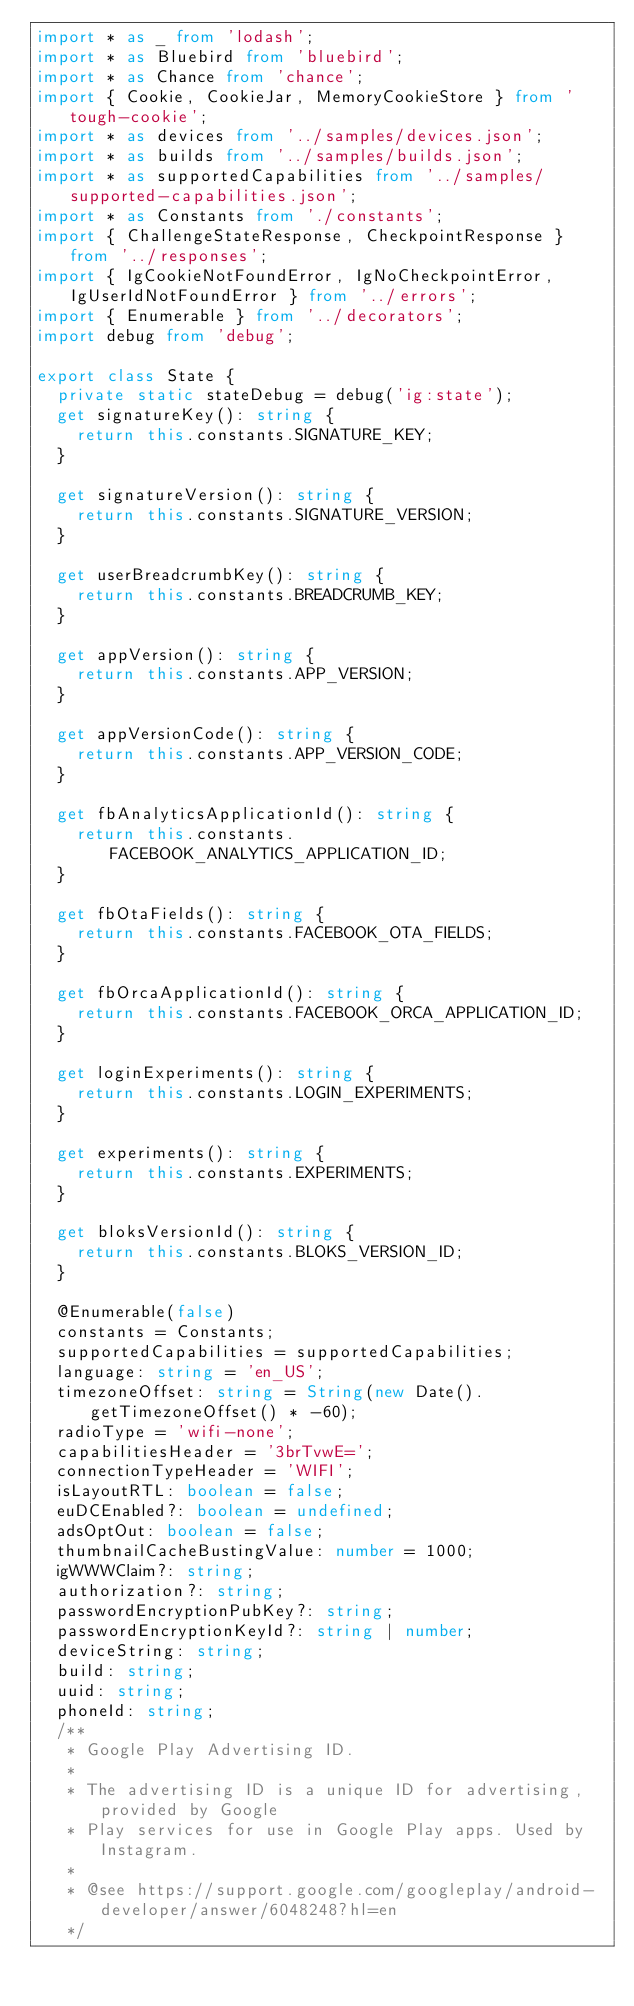Convert code to text. <code><loc_0><loc_0><loc_500><loc_500><_TypeScript_>import * as _ from 'lodash';
import * as Bluebird from 'bluebird';
import * as Chance from 'chance';
import { Cookie, CookieJar, MemoryCookieStore } from 'tough-cookie';
import * as devices from '../samples/devices.json';
import * as builds from '../samples/builds.json';
import * as supportedCapabilities from '../samples/supported-capabilities.json';
import * as Constants from './constants';
import { ChallengeStateResponse, CheckpointResponse } from '../responses';
import { IgCookieNotFoundError, IgNoCheckpointError, IgUserIdNotFoundError } from '../errors';
import { Enumerable } from '../decorators';
import debug from 'debug';

export class State {
  private static stateDebug = debug('ig:state');
  get signatureKey(): string {
    return this.constants.SIGNATURE_KEY;
  }

  get signatureVersion(): string {
    return this.constants.SIGNATURE_VERSION;
  }

  get userBreadcrumbKey(): string {
    return this.constants.BREADCRUMB_KEY;
  }

  get appVersion(): string {
    return this.constants.APP_VERSION;
  }

  get appVersionCode(): string {
    return this.constants.APP_VERSION_CODE;
  }

  get fbAnalyticsApplicationId(): string {
    return this.constants.FACEBOOK_ANALYTICS_APPLICATION_ID;
  }

  get fbOtaFields(): string {
    return this.constants.FACEBOOK_OTA_FIELDS;
  }

  get fbOrcaApplicationId(): string {
    return this.constants.FACEBOOK_ORCA_APPLICATION_ID;
  }

  get loginExperiments(): string {
    return this.constants.LOGIN_EXPERIMENTS;
  }

  get experiments(): string {
    return this.constants.EXPERIMENTS;
  }

  get bloksVersionId(): string {
    return this.constants.BLOKS_VERSION_ID;
  }

  @Enumerable(false)
  constants = Constants;
  supportedCapabilities = supportedCapabilities;
  language: string = 'en_US';
  timezoneOffset: string = String(new Date().getTimezoneOffset() * -60);
  radioType = 'wifi-none';
  capabilitiesHeader = '3brTvwE=';
  connectionTypeHeader = 'WIFI';
  isLayoutRTL: boolean = false;
  euDCEnabled?: boolean = undefined;
  adsOptOut: boolean = false;
  thumbnailCacheBustingValue: number = 1000;
  igWWWClaim?: string;
  authorization?: string;
  passwordEncryptionPubKey?: string;
  passwordEncryptionKeyId?: string | number;
  deviceString: string;
  build: string;
  uuid: string;
  phoneId: string;
  /**
   * Google Play Advertising ID.
   *
   * The advertising ID is a unique ID for advertising, provided by Google
   * Play services for use in Google Play apps. Used by Instagram.
   *
   * @see https://support.google.com/googleplay/android-developer/answer/6048248?hl=en
   */</code> 